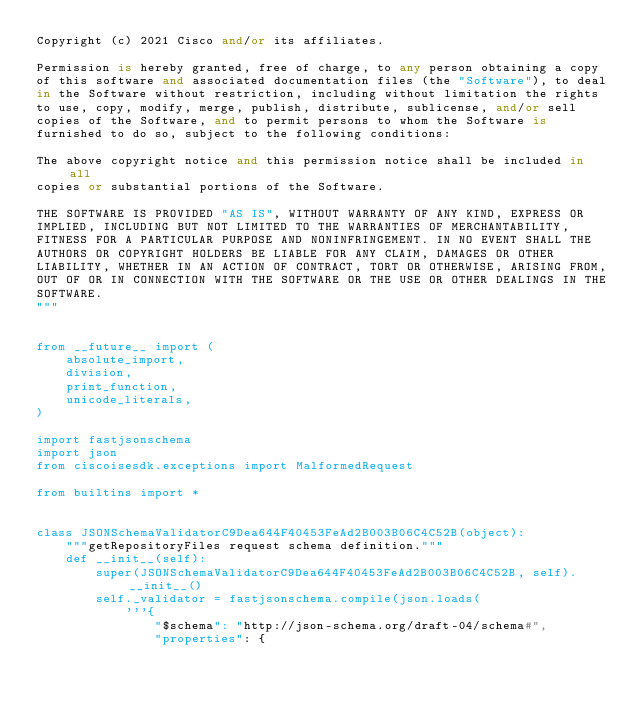Convert code to text. <code><loc_0><loc_0><loc_500><loc_500><_Python_>Copyright (c) 2021 Cisco and/or its affiliates.

Permission is hereby granted, free of charge, to any person obtaining a copy
of this software and associated documentation files (the "Software"), to deal
in the Software without restriction, including without limitation the rights
to use, copy, modify, merge, publish, distribute, sublicense, and/or sell
copies of the Software, and to permit persons to whom the Software is
furnished to do so, subject to the following conditions:

The above copyright notice and this permission notice shall be included in all
copies or substantial portions of the Software.

THE SOFTWARE IS PROVIDED "AS IS", WITHOUT WARRANTY OF ANY KIND, EXPRESS OR
IMPLIED, INCLUDING BUT NOT LIMITED TO THE WARRANTIES OF MERCHANTABILITY,
FITNESS FOR A PARTICULAR PURPOSE AND NONINFRINGEMENT. IN NO EVENT SHALL THE
AUTHORS OR COPYRIGHT HOLDERS BE LIABLE FOR ANY CLAIM, DAMAGES OR OTHER
LIABILITY, WHETHER IN AN ACTION OF CONTRACT, TORT OR OTHERWISE, ARISING FROM,
OUT OF OR IN CONNECTION WITH THE SOFTWARE OR THE USE OR OTHER DEALINGS IN THE
SOFTWARE.
"""


from __future__ import (
    absolute_import,
    division,
    print_function,
    unicode_literals,
)

import fastjsonschema
import json
from ciscoisesdk.exceptions import MalformedRequest

from builtins import *


class JSONSchemaValidatorC9Dea644F40453FeAd2B003B06C4C52B(object):
    """getRepositoryFiles request schema definition."""
    def __init__(self):
        super(JSONSchemaValidatorC9Dea644F40453FeAd2B003B06C4C52B, self).__init__()
        self._validator = fastjsonschema.compile(json.loads(
            '''{
                "$schema": "http://json-schema.org/draft-04/schema#",
                "properties": {</code> 